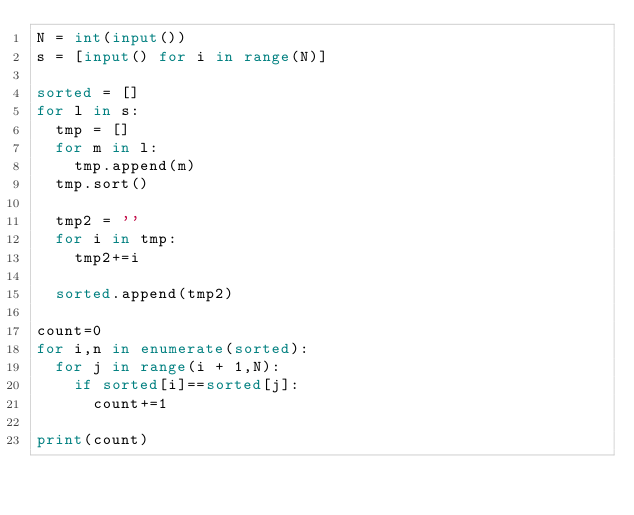Convert code to text. <code><loc_0><loc_0><loc_500><loc_500><_Python_>N = int(input())
s = [input() for i in range(N)]

sorted = []
for l in s:
	tmp = []
	for m in l:
		tmp.append(m)
	tmp.sort()

	tmp2 = ''
	for i in tmp:
		tmp2+=i

	sorted.append(tmp2)

count=0
for i,n in enumerate(sorted):
	for j in range(i + 1,N):
		if sorted[i]==sorted[j]:
			count+=1

print(count)
</code> 